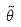<formula> <loc_0><loc_0><loc_500><loc_500>\tilde { \theta }</formula> 